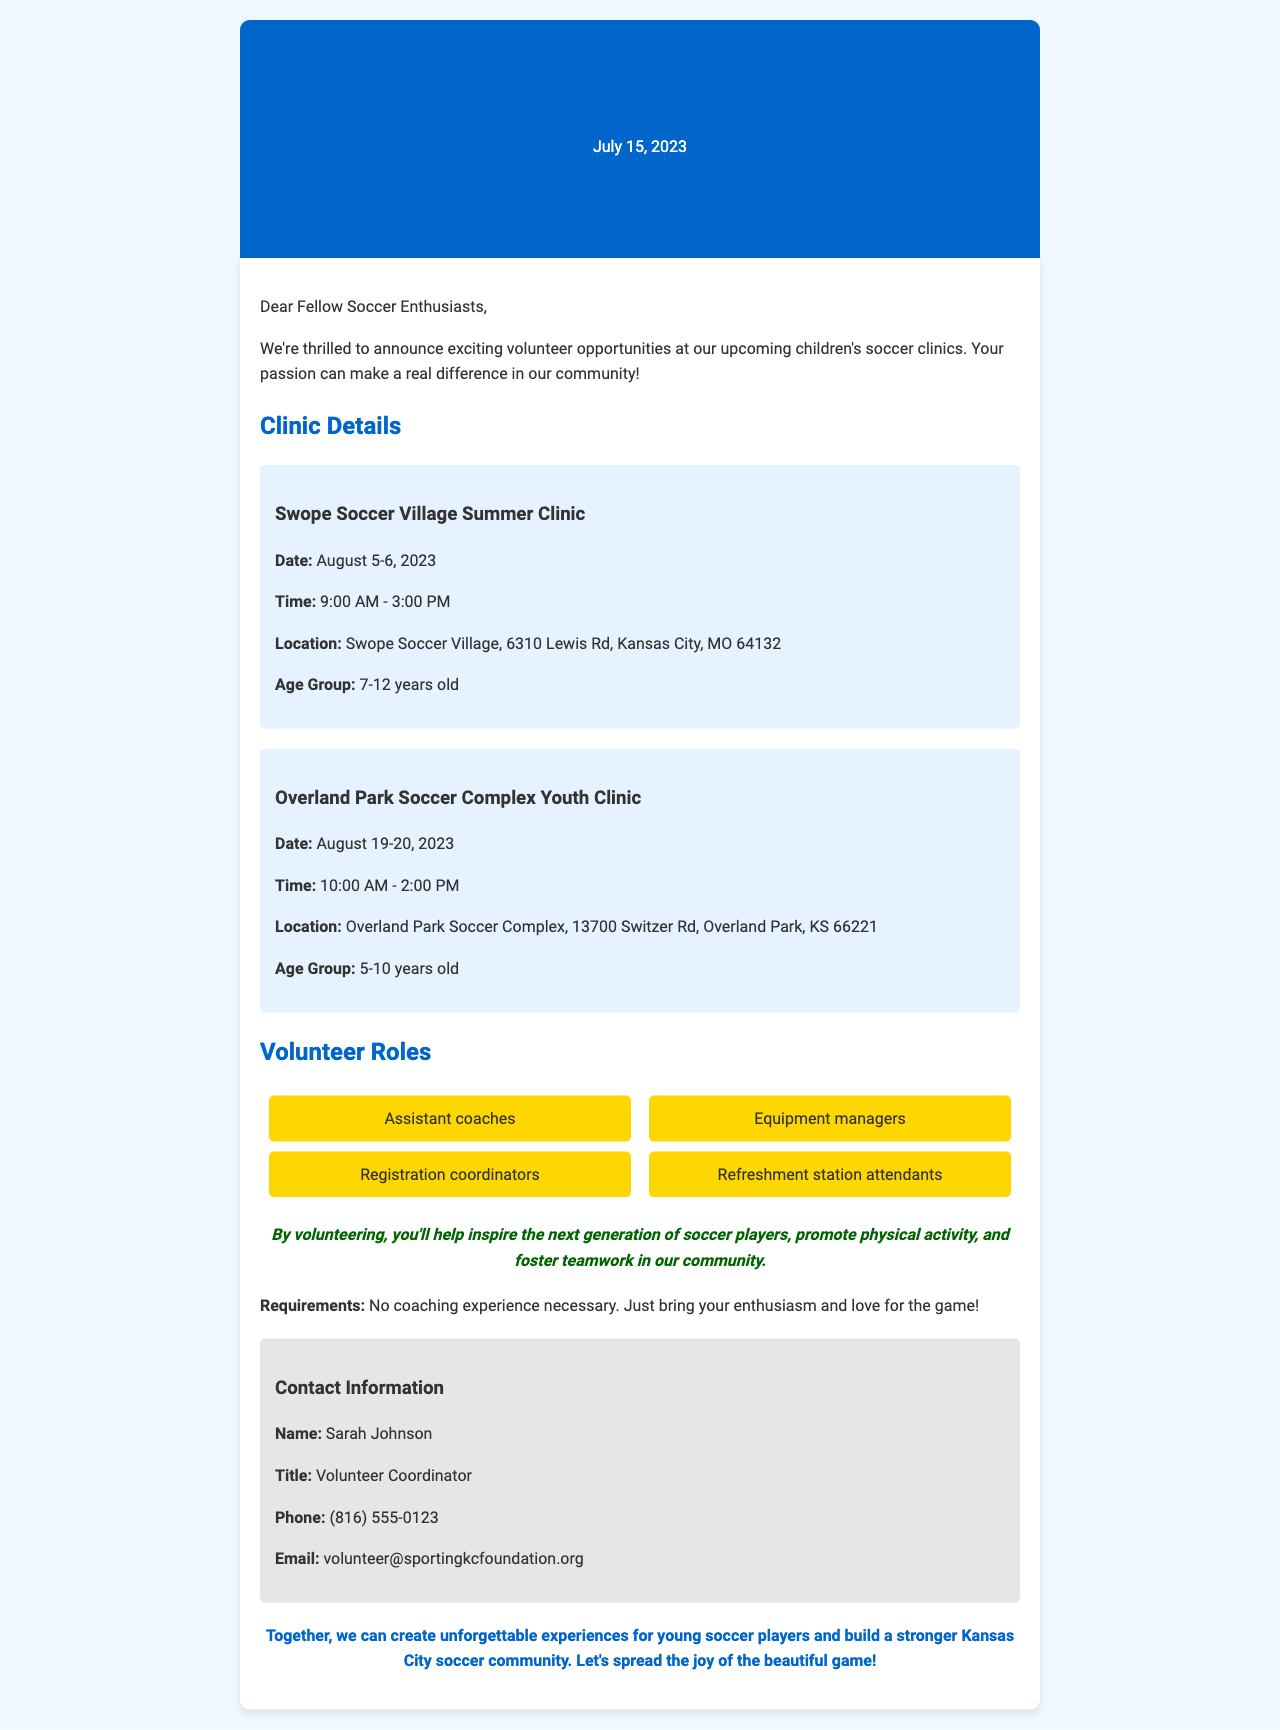What are the dates for the Swope Soccer Village Summer Clinic? The dates for the Swope Soccer Village Summer Clinic are clearly mentioned in the document as August 5-6, 2023.
Answer: August 5-6, 2023 Who is the Volunteer Coordinator? The document specifies that Sarah Johnson is the Volunteer Coordinator.
Answer: Sarah Johnson What age group is targeted at the Overland Park Soccer Complex Youth Clinic? The age group for the Overland Park Soccer Complex Youth Clinic is indicated as 5-10 years old.
Answer: 5-10 years old What is the second volunteer role listed? The document lists the volunteer roles, where the second role is equipment managers.
Answer: Equipment managers What is emphasized about volunteering in the impact statement? The impact statement in the document emphasizes that volunteering helps inspire the next generation of soccer players.
Answer: Inspire the next generation of soccer players What is required to volunteer according to the document? The document states that no coaching experience is necessary to volunteer, just enthusiasm and love for the game.
Answer: No coaching experience necessary How long is the Swope Soccer Village Summer Clinic each day? The clinic details mention that the Swope Soccer Village Summer Clinic runs from 9:00 AM to 3:00 PM each day.
Answer: 9:00 AM - 3:00 PM What type of document is this? The structure and content of the document indicate that it is a fax detailing volunteer opportunities.
Answer: Fax detailing volunteer opportunities 